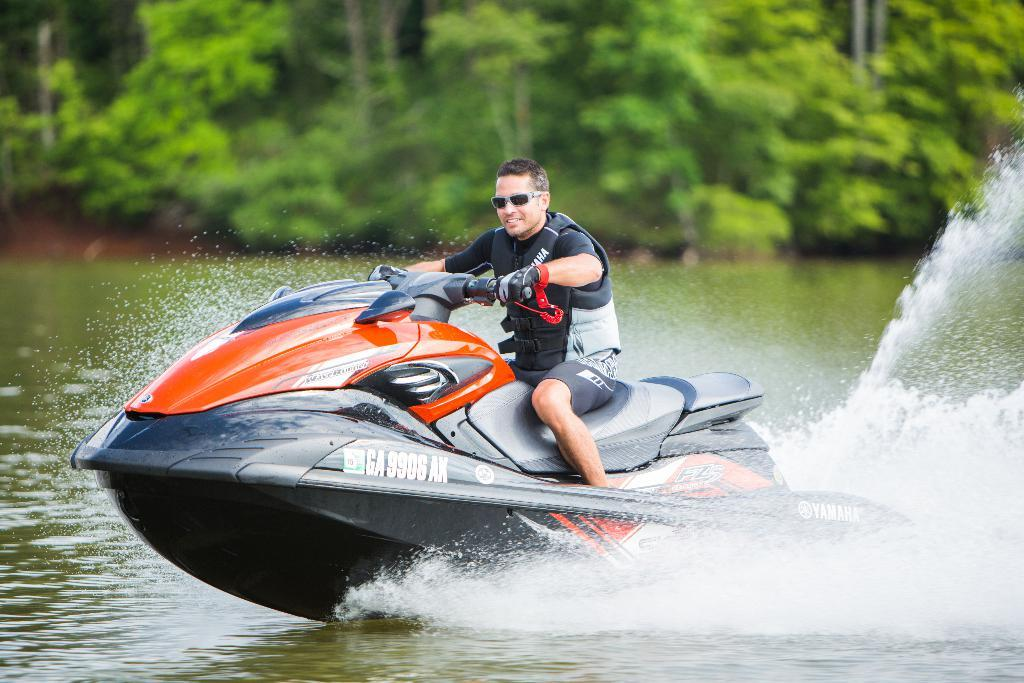What is the main subject of the image? The main subject of the image is a jet ski. Where is the jet ski located? The jet ski is on the water. Who is on the jet ski? There is a man sitting on the jet ski. What can be seen in the background of the image? There are trees in the background of the image. Can you see a crook hiding behind the trees in the image? There is no crook present in the image; it only features a jet ski on the water with a man sitting on it and trees in the background. 